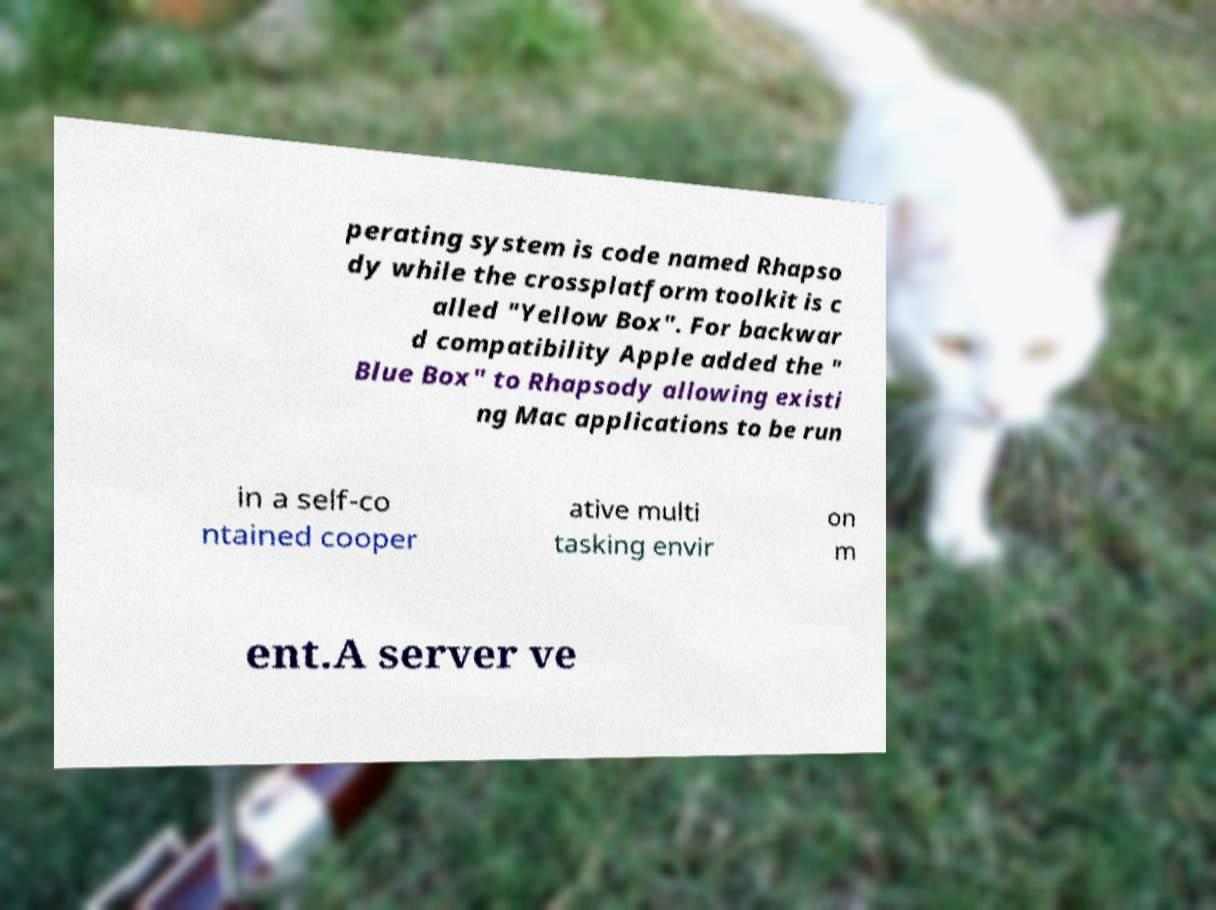What messages or text are displayed in this image? I need them in a readable, typed format. perating system is code named Rhapso dy while the crossplatform toolkit is c alled "Yellow Box". For backwar d compatibility Apple added the " Blue Box" to Rhapsody allowing existi ng Mac applications to be run in a self-co ntained cooper ative multi tasking envir on m ent.A server ve 